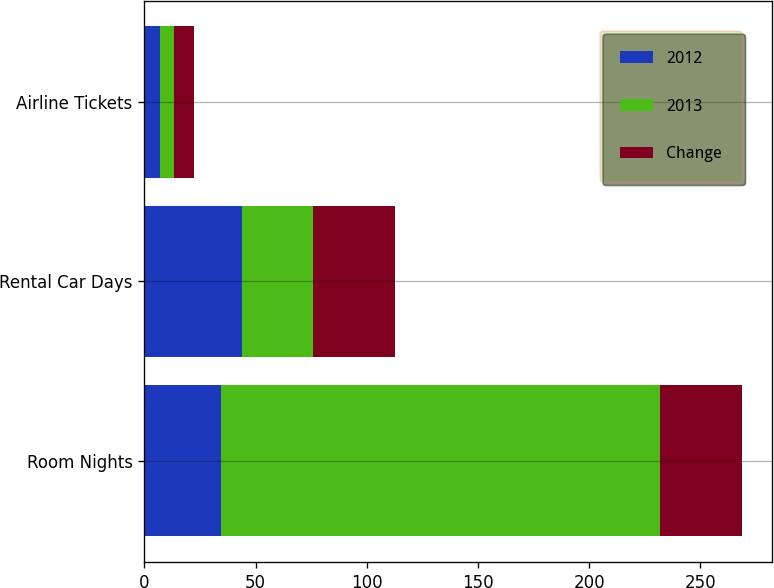Convert chart to OTSL. <chart><loc_0><loc_0><loc_500><loc_500><stacked_bar_chart><ecel><fcel>Room Nights<fcel>Rental Car Days<fcel>Airline Tickets<nl><fcel>2012<fcel>34.45<fcel>43.9<fcel>7<nl><fcel>2013<fcel>197.5<fcel>32<fcel>6.4<nl><fcel>Change<fcel>36.9<fcel>37<fcel>9.1<nl></chart> 